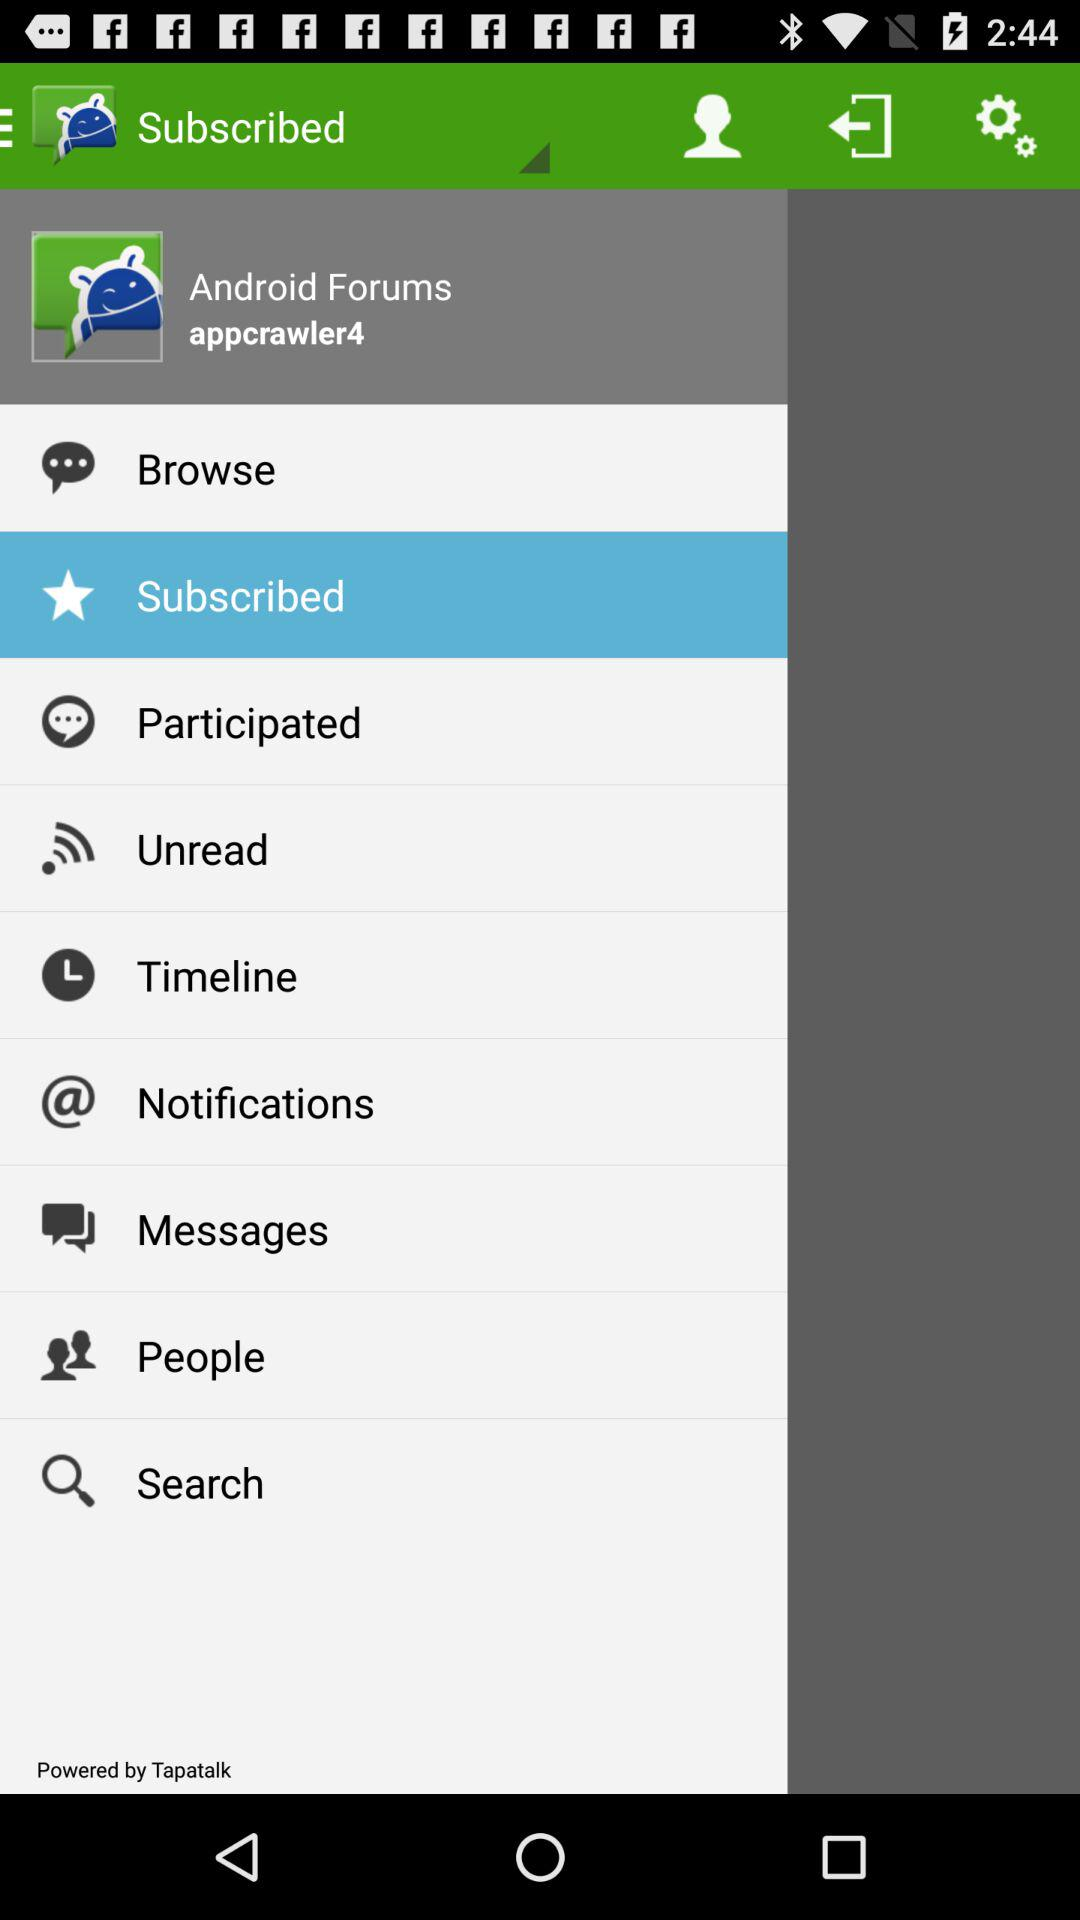How many messages are unread?
When the provided information is insufficient, respond with <no answer>. <no answer> 